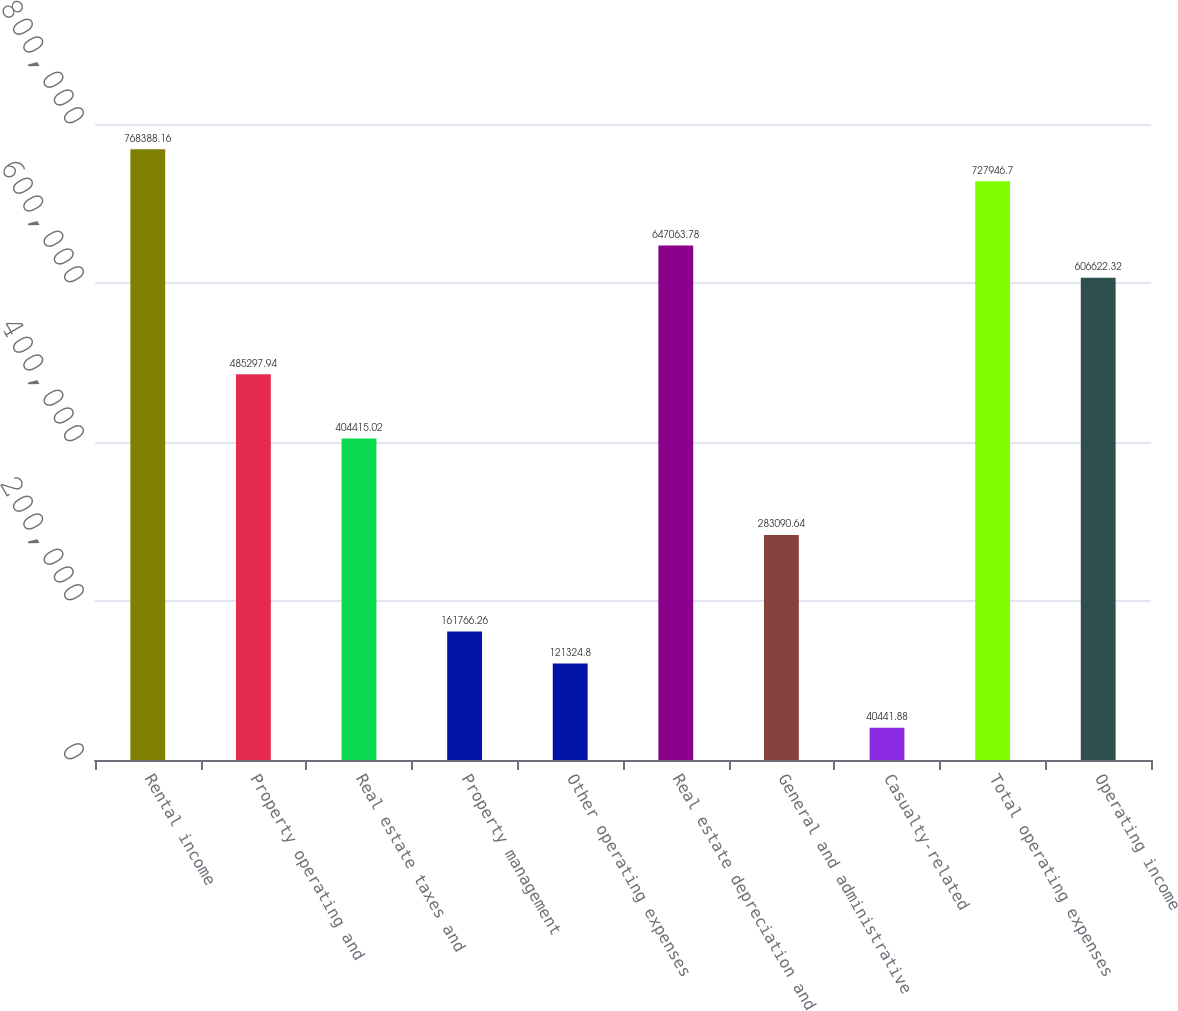<chart> <loc_0><loc_0><loc_500><loc_500><bar_chart><fcel>Rental income<fcel>Property operating and<fcel>Real estate taxes and<fcel>Property management<fcel>Other operating expenses<fcel>Real estate depreciation and<fcel>General and administrative<fcel>Casualty-related<fcel>Total operating expenses<fcel>Operating income<nl><fcel>768388<fcel>485298<fcel>404415<fcel>161766<fcel>121325<fcel>647064<fcel>283091<fcel>40441.9<fcel>727947<fcel>606622<nl></chart> 